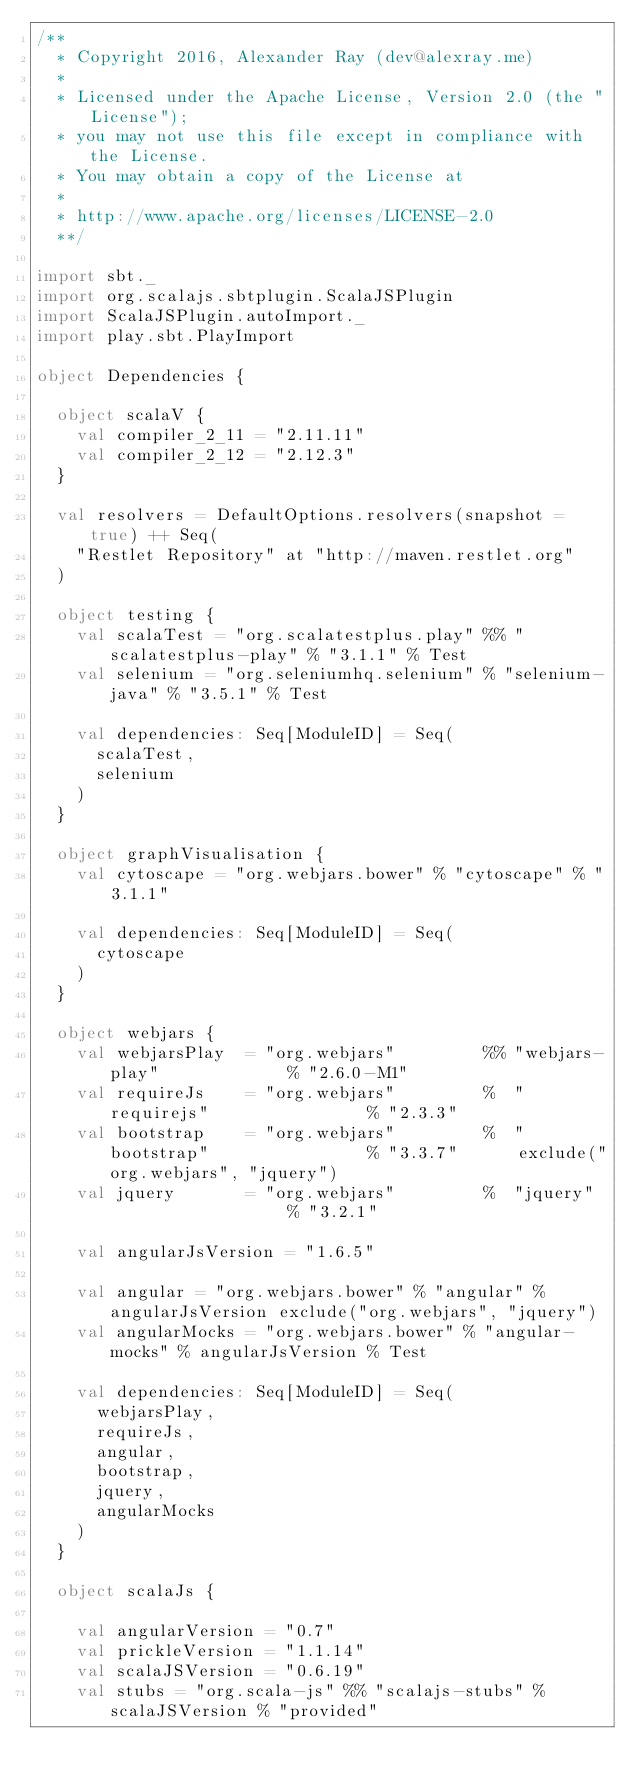<code> <loc_0><loc_0><loc_500><loc_500><_Scala_>/**
  * Copyright 2016, Alexander Ray (dev@alexray.me)
  *
  * Licensed under the Apache License, Version 2.0 (the "License");
  * you may not use this file except in compliance with the License.
  * You may obtain a copy of the License at
  *
  * http://www.apache.org/licenses/LICENSE-2.0
  **/

import sbt._
import org.scalajs.sbtplugin.ScalaJSPlugin
import ScalaJSPlugin.autoImport._
import play.sbt.PlayImport

object Dependencies {

  object scalaV {
    val compiler_2_11 = "2.11.11"
    val compiler_2_12 = "2.12.3"
  }

  val resolvers = DefaultOptions.resolvers(snapshot = true) ++ Seq(
    "Restlet Repository" at "http://maven.restlet.org"
  )

  object testing {
    val scalaTest = "org.scalatestplus.play" %% "scalatestplus-play" % "3.1.1" % Test
    val selenium = "org.seleniumhq.selenium" % "selenium-java" % "3.5.1" % Test

    val dependencies: Seq[ModuleID] = Seq(
      scalaTest,
      selenium
    )
  }

  object graphVisualisation {
    val cytoscape = "org.webjars.bower" % "cytoscape" % "3.1.1"

    val dependencies: Seq[ModuleID] = Seq(
      cytoscape
    )
  }

  object webjars {
    val webjarsPlay  = "org.webjars"         %% "webjars-play"             % "2.6.0-M1"
    val requireJs    = "org.webjars"         %  "requirejs"                % "2.3.3"
    val bootstrap    = "org.webjars"         %  "bootstrap"                % "3.3.7"      exclude("org.webjars", "jquery")
    val jquery       = "org.webjars"         %  "jquery"                   % "3.2.1"

    val angularJsVersion = "1.6.5"

    val angular = "org.webjars.bower" % "angular" % angularJsVersion exclude("org.webjars", "jquery")
    val angularMocks = "org.webjars.bower" % "angular-mocks" % angularJsVersion % Test

    val dependencies: Seq[ModuleID] = Seq(
      webjarsPlay,
      requireJs,
      angular,
      bootstrap,
      jquery,
      angularMocks
    )
  }

  object scalaJs {

    val angularVersion = "0.7"
    val prickleVersion = "1.1.14"
    val scalaJSVersion = "0.6.19"
    val stubs = "org.scala-js" %% "scalajs-stubs" % scalaJSVersion % "provided"</code> 